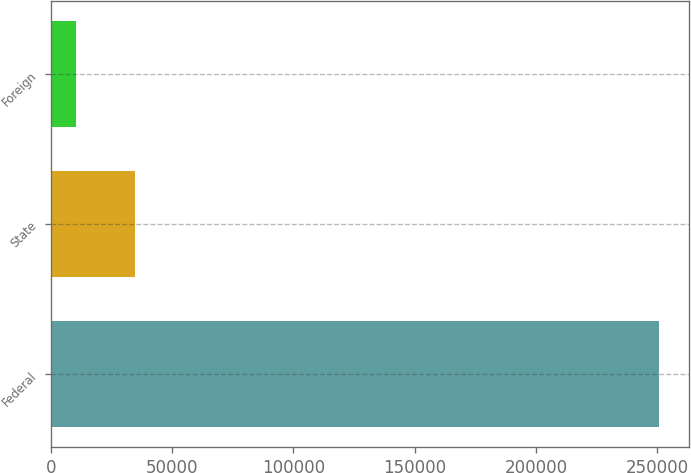<chart> <loc_0><loc_0><loc_500><loc_500><bar_chart><fcel>Federal<fcel>State<fcel>Foreign<nl><fcel>250527<fcel>34518.9<fcel>10518<nl></chart> 